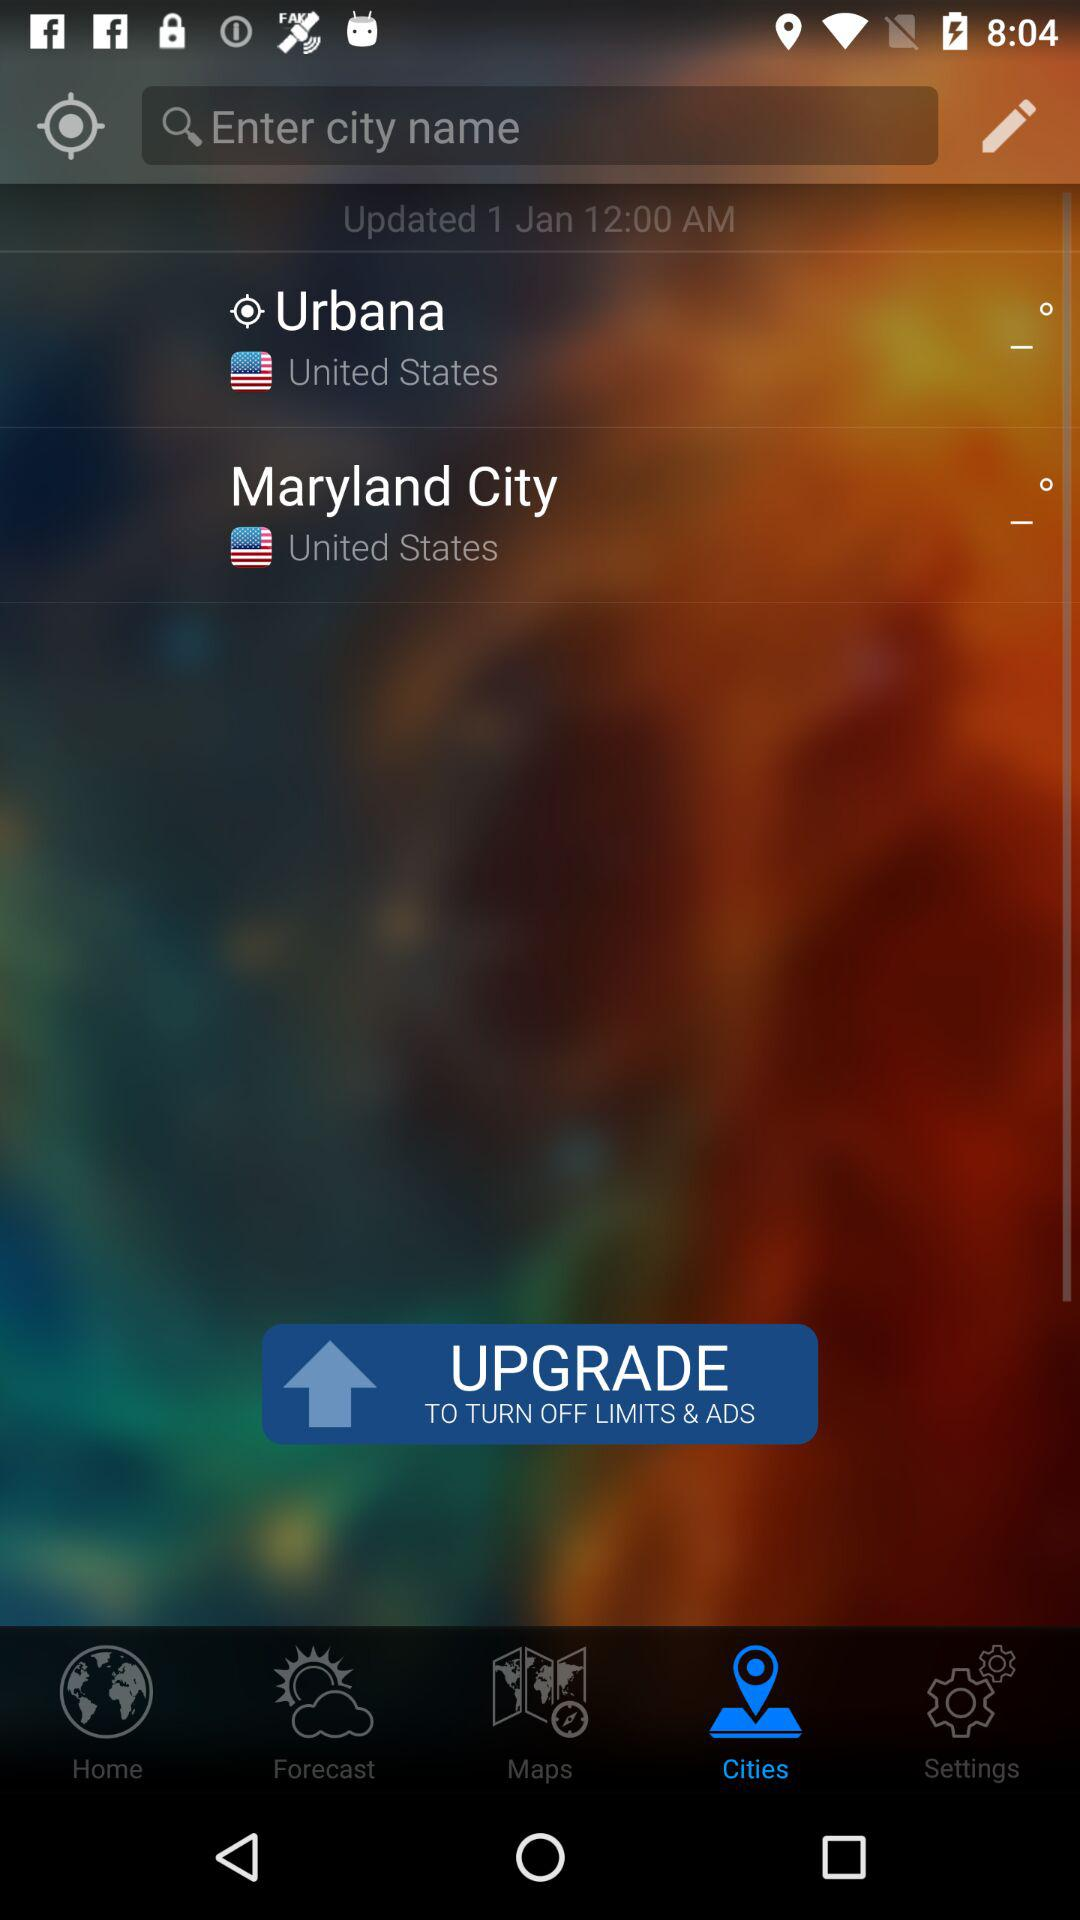Which tab is selected? The selected tab is "Cities". 